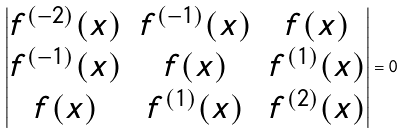Convert formula to latex. <formula><loc_0><loc_0><loc_500><loc_500>\left | \begin{matrix} f ^ { ( - 2 ) } ( x ) & f ^ { ( - 1 ) } ( x ) & f ( x ) \\ f ^ { ( - 1 ) } ( x ) & f ( x ) & f ^ { ( 1 ) } ( x ) \\ f ( x ) & f ^ { ( 1 ) } ( x ) & f ^ { ( 2 ) } ( x ) \end{matrix} \right | = 0</formula> 